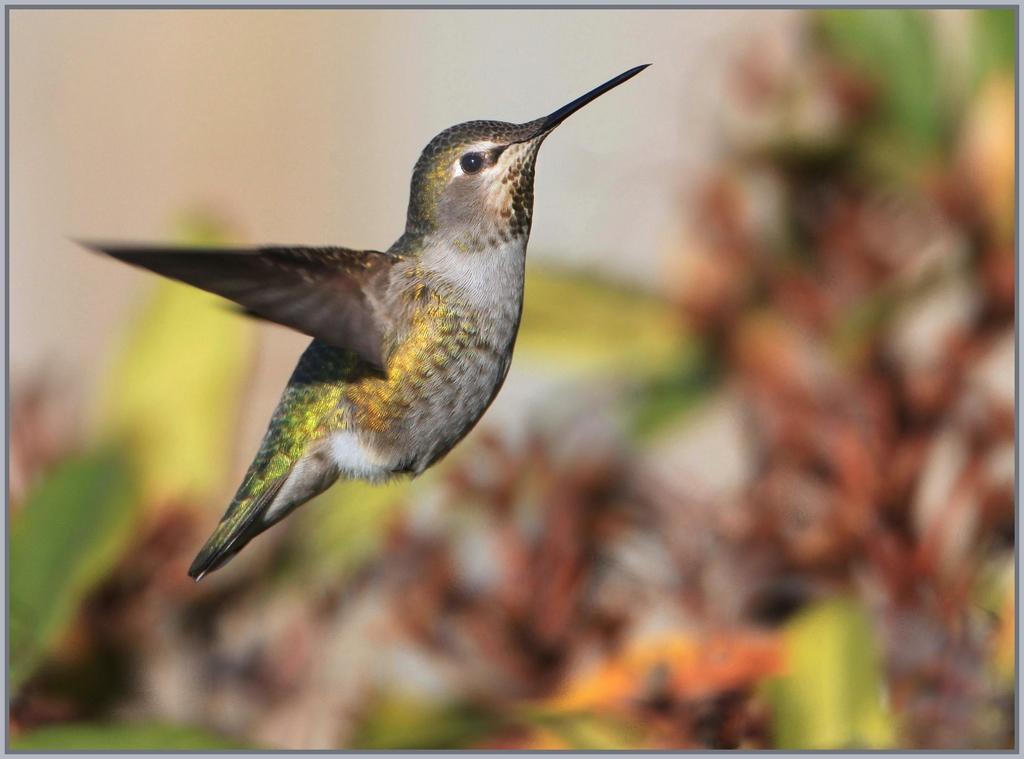Describe this image in one or two sentences. This is the humming bird, which is flying. The background looks blurred. 